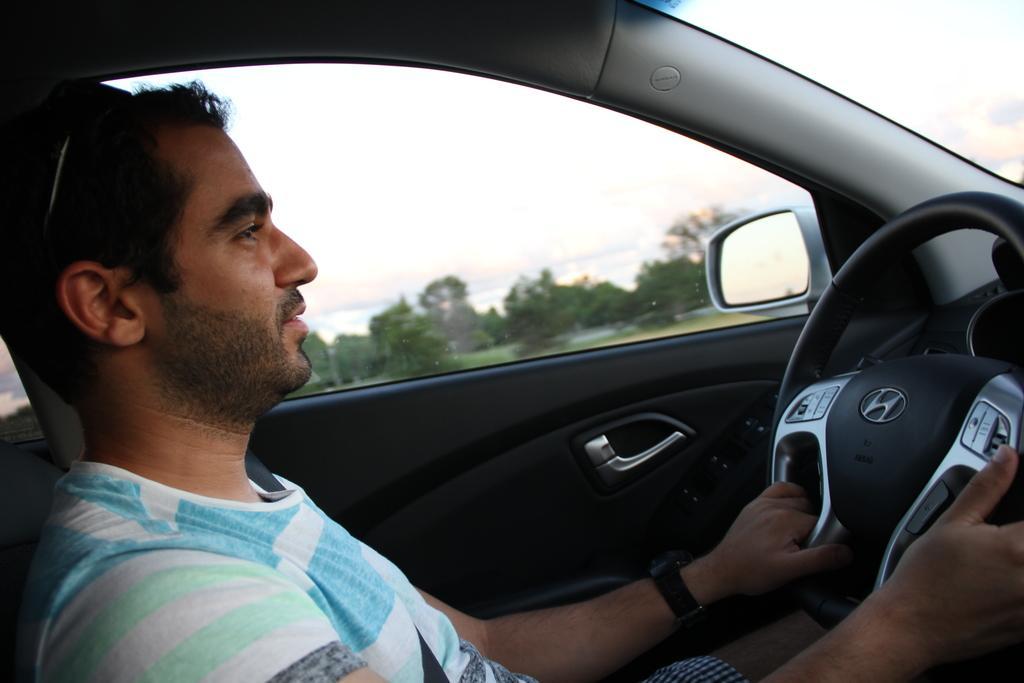Please provide a concise description of this image. In this image there is a person inside the car, there is a mirror, door, steering, visible, through the window of the car I can see the sky , trees. 